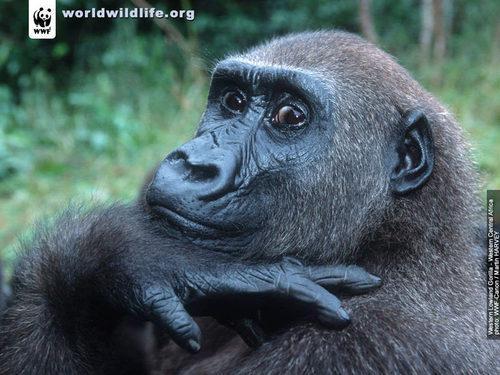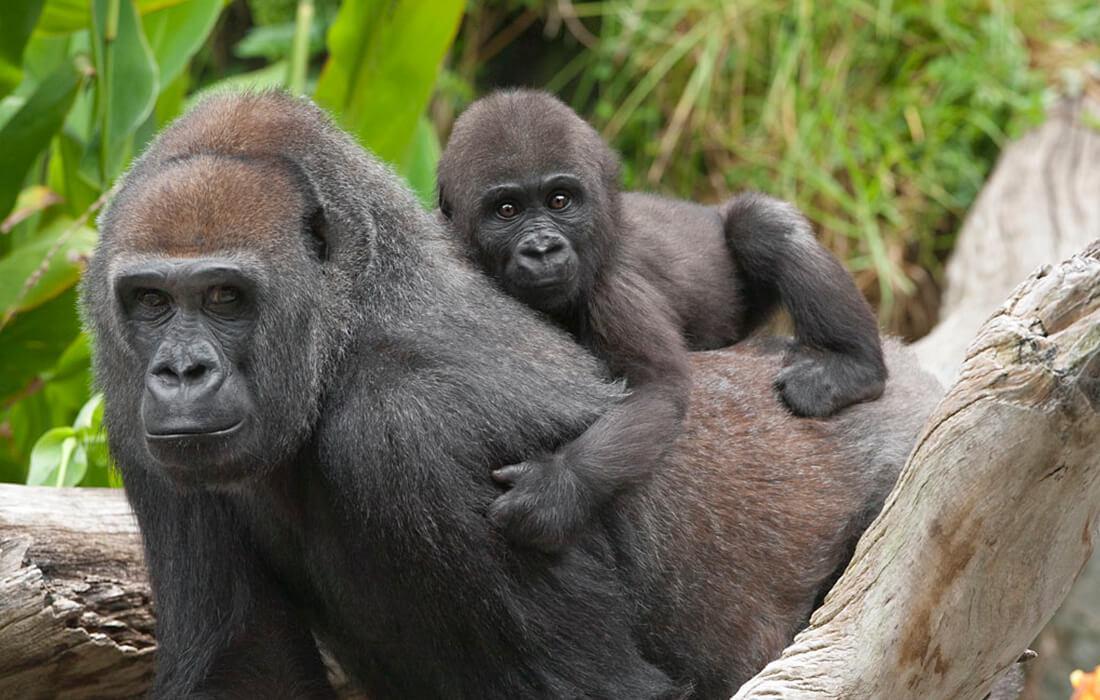The first image is the image on the left, the second image is the image on the right. For the images shown, is this caption "An image shows a baby gorilla with an adult gorilla." true? Answer yes or no. Yes. The first image is the image on the left, the second image is the image on the right. Considering the images on both sides, is "There are a total of 2 gorillas in each pair of images." valid? Answer yes or no. No. 